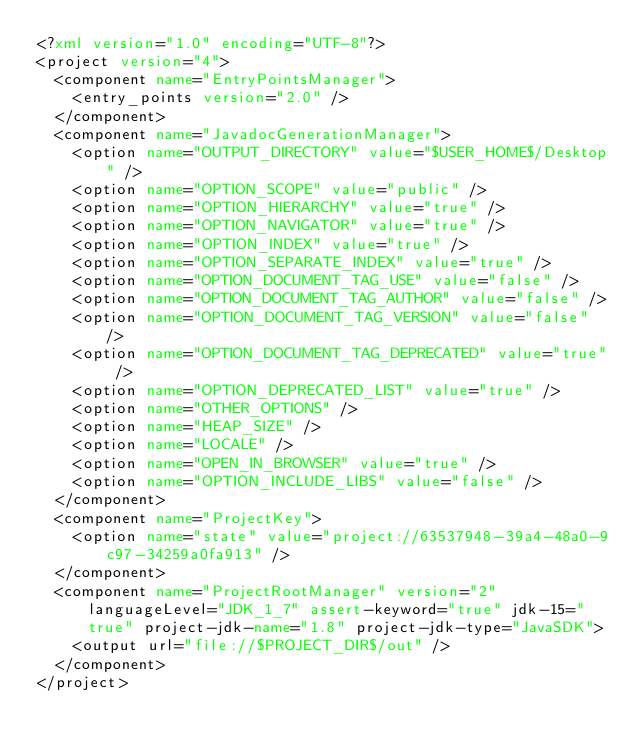<code> <loc_0><loc_0><loc_500><loc_500><_XML_><?xml version="1.0" encoding="UTF-8"?>
<project version="4">
  <component name="EntryPointsManager">
    <entry_points version="2.0" />
  </component>
  <component name="JavadocGenerationManager">
    <option name="OUTPUT_DIRECTORY" value="$USER_HOME$/Desktop" />
    <option name="OPTION_SCOPE" value="public" />
    <option name="OPTION_HIERARCHY" value="true" />
    <option name="OPTION_NAVIGATOR" value="true" />
    <option name="OPTION_INDEX" value="true" />
    <option name="OPTION_SEPARATE_INDEX" value="true" />
    <option name="OPTION_DOCUMENT_TAG_USE" value="false" />
    <option name="OPTION_DOCUMENT_TAG_AUTHOR" value="false" />
    <option name="OPTION_DOCUMENT_TAG_VERSION" value="false" />
    <option name="OPTION_DOCUMENT_TAG_DEPRECATED" value="true" />
    <option name="OPTION_DEPRECATED_LIST" value="true" />
    <option name="OTHER_OPTIONS" />
    <option name="HEAP_SIZE" />
    <option name="LOCALE" />
    <option name="OPEN_IN_BROWSER" value="true" />
    <option name="OPTION_INCLUDE_LIBS" value="false" />
  </component>
  <component name="ProjectKey">
    <option name="state" value="project://63537948-39a4-48a0-9c97-34259a0fa913" />
  </component>
  <component name="ProjectRootManager" version="2" languageLevel="JDK_1_7" assert-keyword="true" jdk-15="true" project-jdk-name="1.8" project-jdk-type="JavaSDK">
    <output url="file://$PROJECT_DIR$/out" />
  </component>
</project></code> 